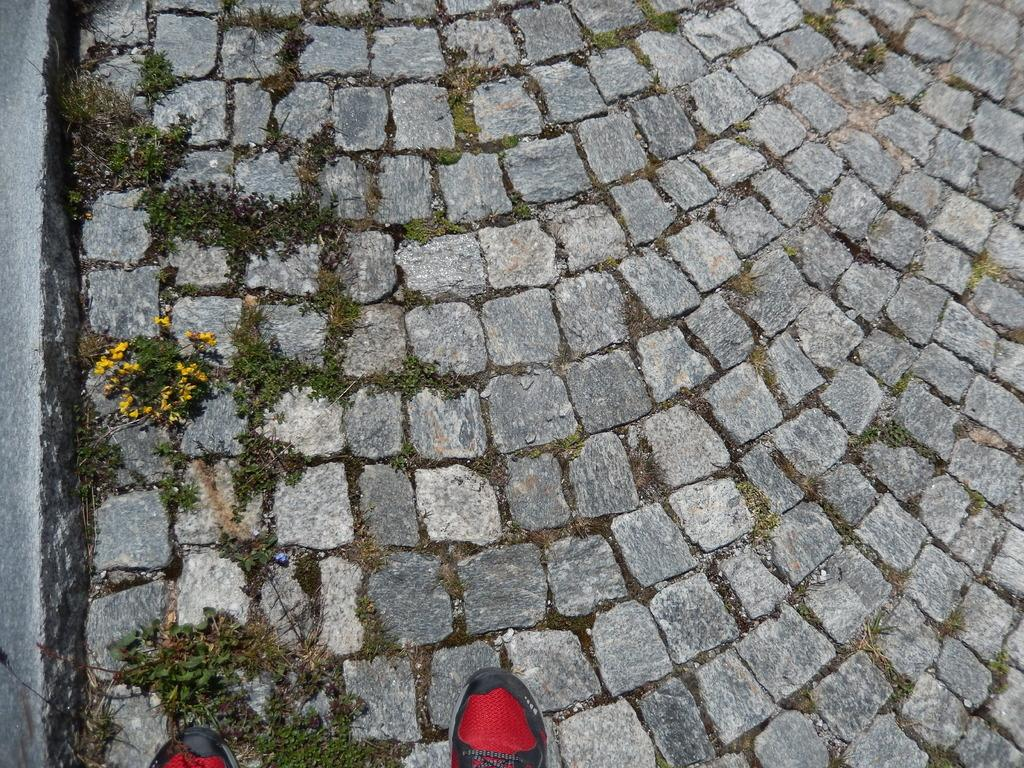What type of flooring is visible in the image? The image contains stone floors. What type of vegetation is present in the image? There is grass in the image. What type of flowers can be seen in the image? There are yellow flowers on the left side of the image. What objects are located at the bottom of the image? There are two shoes at the bottom of the image. What type of business is being conducted in the image? There is no indication of any business being conducted in the image. What month is it in the image? The image does not provide any information about the month. 